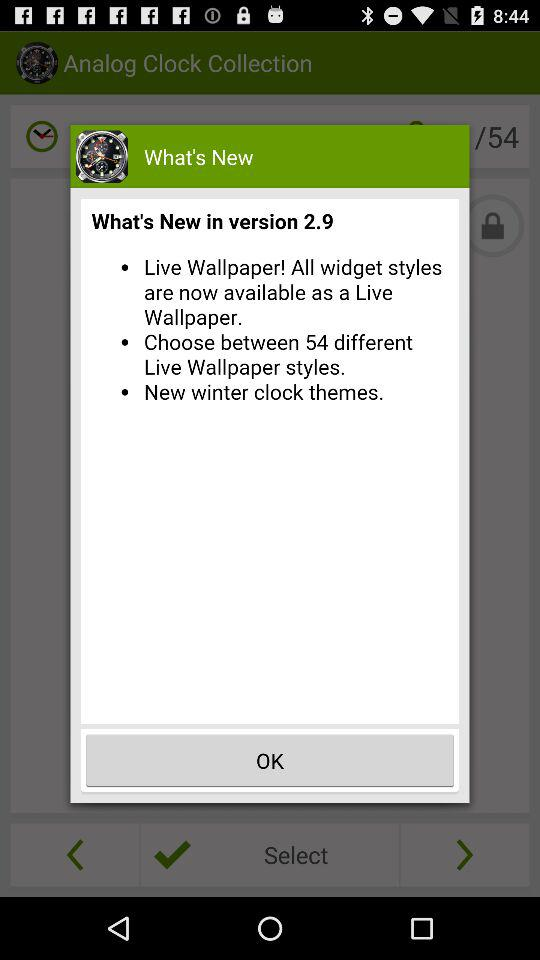How many new features did version 2.8 provide?
When the provided information is insufficient, respond with <no answer>. <no answer> 